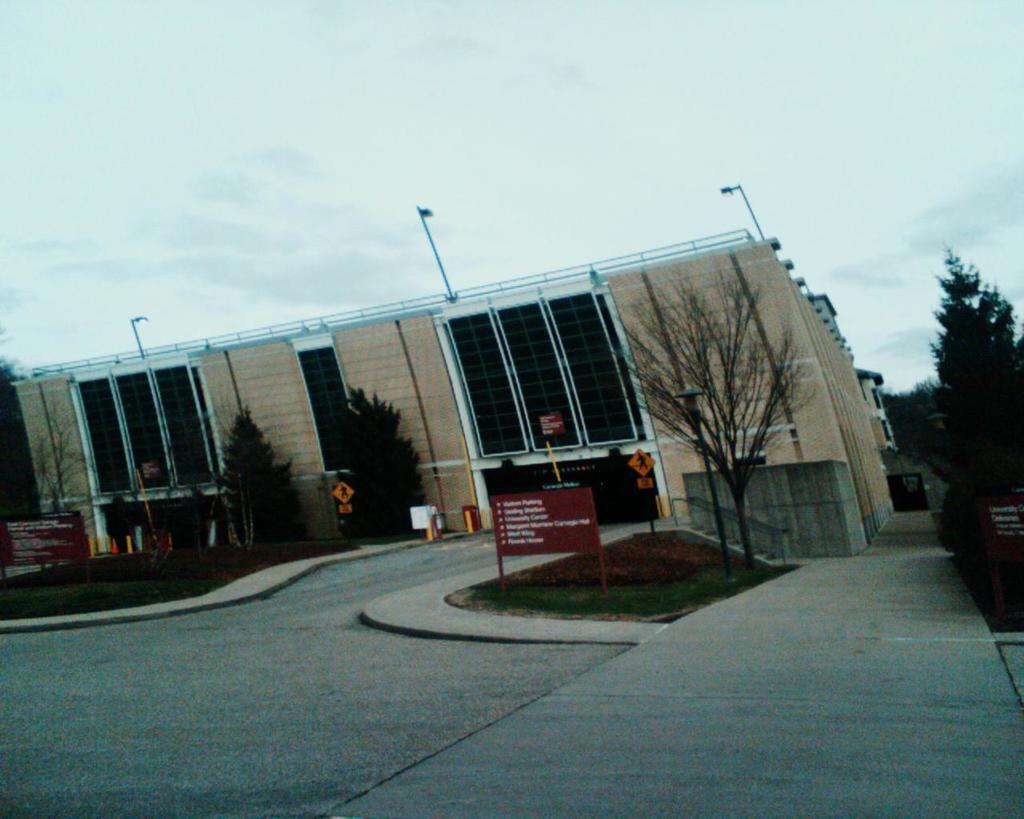How would you summarize this image in a sentence or two? In the middle of the image we can see some trees, poles, banners and sign boards. Behind them we can see a building. At the top of the image we can see some clouds in the sky. 